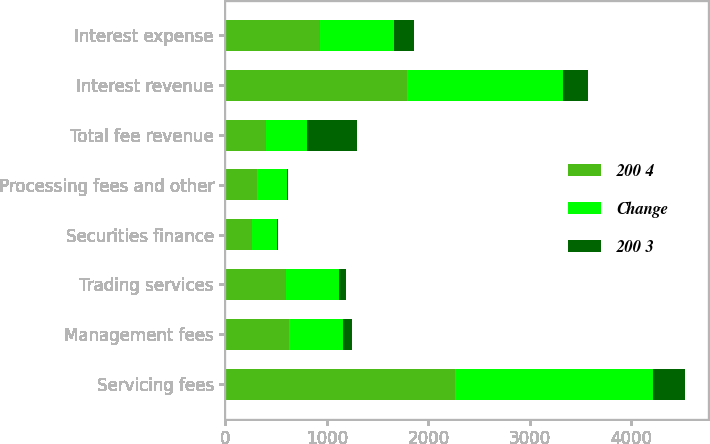<chart> <loc_0><loc_0><loc_500><loc_500><stacked_bar_chart><ecel><fcel>Servicing fees<fcel>Management fees<fcel>Trading services<fcel>Securities finance<fcel>Processing fees and other<fcel>Total fee revenue<fcel>Interest revenue<fcel>Interest expense<nl><fcel>200 4<fcel>2263<fcel>623<fcel>595<fcel>259<fcel>308<fcel>402.5<fcel>1787<fcel>928<nl><fcel>Change<fcel>1950<fcel>533<fcel>529<fcel>245<fcel>299<fcel>402.5<fcel>1539<fcel>729<nl><fcel>200 3<fcel>313<fcel>90<fcel>66<fcel>14<fcel>9<fcel>492<fcel>248<fcel>199<nl></chart> 